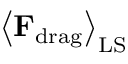Convert formula to latex. <formula><loc_0><loc_0><loc_500><loc_500>\left \langle { F } _ { d r a g } \right \rangle _ { L S }</formula> 